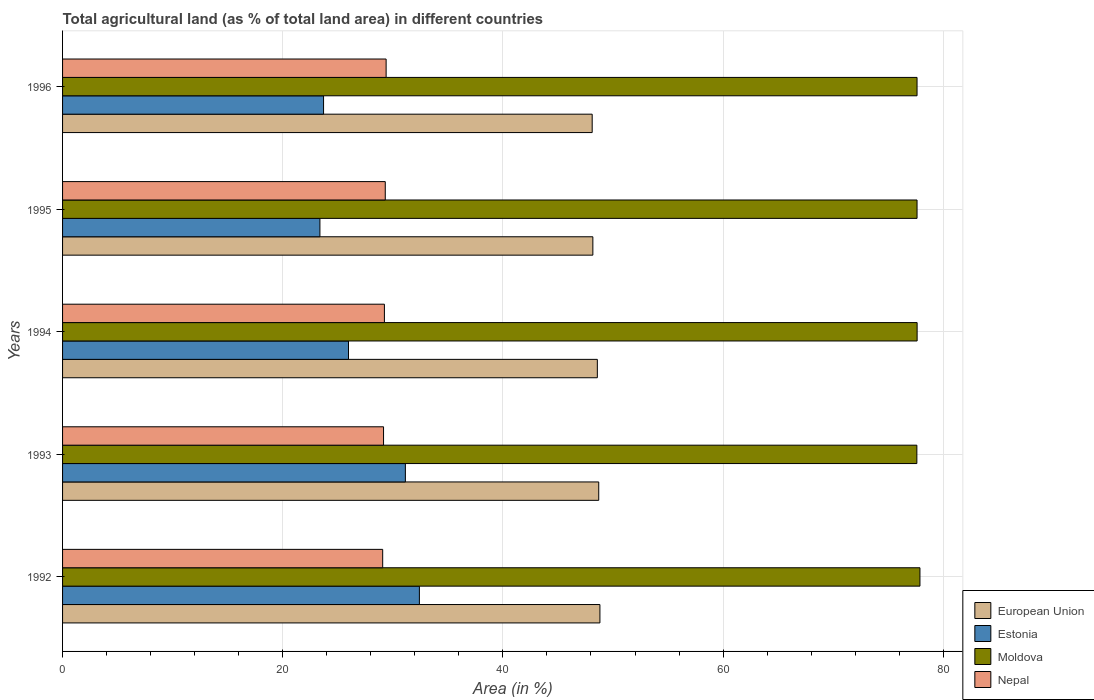How many different coloured bars are there?
Provide a short and direct response. 4. Are the number of bars per tick equal to the number of legend labels?
Provide a succinct answer. Yes. What is the label of the 4th group of bars from the top?
Provide a succinct answer. 1993. In how many cases, is the number of bars for a given year not equal to the number of legend labels?
Give a very brief answer. 0. What is the percentage of agricultural land in Moldova in 1992?
Your answer should be very brief. 77.88. Across all years, what is the maximum percentage of agricultural land in European Union?
Give a very brief answer. 48.81. Across all years, what is the minimum percentage of agricultural land in Estonia?
Keep it short and to the point. 23.38. In which year was the percentage of agricultural land in Estonia maximum?
Make the answer very short. 1992. What is the total percentage of agricultural land in Moldova in the graph?
Your answer should be compact. 388.35. What is the difference between the percentage of agricultural land in Moldova in 1994 and that in 1996?
Provide a succinct answer. 0.01. What is the difference between the percentage of agricultural land in Nepal in 1996 and the percentage of agricultural land in Estonia in 1995?
Offer a terse response. 6.01. What is the average percentage of agricultural land in Nepal per year?
Offer a terse response. 29.23. In the year 1996, what is the difference between the percentage of agricultural land in Estonia and percentage of agricultural land in Nepal?
Provide a short and direct response. -5.68. In how many years, is the percentage of agricultural land in Moldova greater than 72 %?
Your response must be concise. 5. What is the ratio of the percentage of agricultural land in Estonia in 1994 to that in 1995?
Offer a terse response. 1.11. Is the percentage of agricultural land in Moldova in 1995 less than that in 1996?
Keep it short and to the point. No. Is the difference between the percentage of agricultural land in Estonia in 1992 and 1996 greater than the difference between the percentage of agricultural land in Nepal in 1992 and 1996?
Give a very brief answer. Yes. What is the difference between the highest and the second highest percentage of agricultural land in Estonia?
Your answer should be compact. 1.27. What is the difference between the highest and the lowest percentage of agricultural land in European Union?
Your answer should be very brief. 0.7. Is the sum of the percentage of agricultural land in European Union in 1992 and 1995 greater than the maximum percentage of agricultural land in Estonia across all years?
Provide a succinct answer. Yes. What does the 1st bar from the top in 1992 represents?
Give a very brief answer. Nepal. What does the 1st bar from the bottom in 1993 represents?
Make the answer very short. European Union. Where does the legend appear in the graph?
Your response must be concise. Bottom right. How many legend labels are there?
Offer a very short reply. 4. How are the legend labels stacked?
Make the answer very short. Vertical. What is the title of the graph?
Provide a short and direct response. Total agricultural land (as % of total land area) in different countries. What is the label or title of the X-axis?
Your answer should be compact. Area (in %). What is the label or title of the Y-axis?
Offer a terse response. Years. What is the Area (in %) of European Union in 1992?
Make the answer very short. 48.81. What is the Area (in %) of Estonia in 1992?
Ensure brevity in your answer.  32.41. What is the Area (in %) in Moldova in 1992?
Offer a very short reply. 77.88. What is the Area (in %) of Nepal in 1992?
Give a very brief answer. 29.08. What is the Area (in %) in European Union in 1993?
Give a very brief answer. 48.7. What is the Area (in %) of Estonia in 1993?
Your answer should be very brief. 31.14. What is the Area (in %) of Moldova in 1993?
Keep it short and to the point. 77.6. What is the Area (in %) in Nepal in 1993?
Your answer should be very brief. 29.16. What is the Area (in %) of European Union in 1994?
Give a very brief answer. 48.58. What is the Area (in %) in Estonia in 1994?
Your answer should be compact. 25.97. What is the Area (in %) of Moldova in 1994?
Give a very brief answer. 77.63. What is the Area (in %) of Nepal in 1994?
Offer a terse response. 29.23. What is the Area (in %) in European Union in 1995?
Provide a short and direct response. 48.17. What is the Area (in %) in Estonia in 1995?
Provide a short and direct response. 23.38. What is the Area (in %) in Moldova in 1995?
Your answer should be very brief. 77.62. What is the Area (in %) of Nepal in 1995?
Offer a very short reply. 29.31. What is the Area (in %) of European Union in 1996?
Your answer should be compact. 48.11. What is the Area (in %) of Estonia in 1996?
Offer a very short reply. 23.71. What is the Area (in %) in Moldova in 1996?
Provide a short and direct response. 77.62. What is the Area (in %) of Nepal in 1996?
Give a very brief answer. 29.39. Across all years, what is the maximum Area (in %) of European Union?
Offer a very short reply. 48.81. Across all years, what is the maximum Area (in %) in Estonia?
Give a very brief answer. 32.41. Across all years, what is the maximum Area (in %) of Moldova?
Your response must be concise. 77.88. Across all years, what is the maximum Area (in %) in Nepal?
Offer a terse response. 29.39. Across all years, what is the minimum Area (in %) in European Union?
Your response must be concise. 48.11. Across all years, what is the minimum Area (in %) in Estonia?
Keep it short and to the point. 23.38. Across all years, what is the minimum Area (in %) of Moldova?
Your response must be concise. 77.6. Across all years, what is the minimum Area (in %) in Nepal?
Your answer should be compact. 29.08. What is the total Area (in %) in European Union in the graph?
Make the answer very short. 242.37. What is the total Area (in %) in Estonia in the graph?
Your answer should be very brief. 136.61. What is the total Area (in %) in Moldova in the graph?
Your answer should be compact. 388.35. What is the total Area (in %) in Nepal in the graph?
Make the answer very short. 146.17. What is the difference between the Area (in %) in European Union in 1992 and that in 1993?
Provide a succinct answer. 0.11. What is the difference between the Area (in %) of Estonia in 1992 and that in 1993?
Keep it short and to the point. 1.27. What is the difference between the Area (in %) of Moldova in 1992 and that in 1993?
Offer a very short reply. 0.28. What is the difference between the Area (in %) of Nepal in 1992 and that in 1993?
Offer a terse response. -0.08. What is the difference between the Area (in %) of European Union in 1992 and that in 1994?
Make the answer very short. 0.23. What is the difference between the Area (in %) in Estonia in 1992 and that in 1994?
Keep it short and to the point. 6.44. What is the difference between the Area (in %) in Moldova in 1992 and that in 1994?
Your response must be concise. 0.26. What is the difference between the Area (in %) in Nepal in 1992 and that in 1994?
Your response must be concise. -0.16. What is the difference between the Area (in %) in European Union in 1992 and that in 1995?
Offer a very short reply. 0.64. What is the difference between the Area (in %) in Estonia in 1992 and that in 1995?
Keep it short and to the point. 9.04. What is the difference between the Area (in %) of Moldova in 1992 and that in 1995?
Ensure brevity in your answer.  0.26. What is the difference between the Area (in %) of Nepal in 1992 and that in 1995?
Give a very brief answer. -0.23. What is the difference between the Area (in %) in European Union in 1992 and that in 1996?
Give a very brief answer. 0.7. What is the difference between the Area (in %) of Estonia in 1992 and that in 1996?
Keep it short and to the point. 8.7. What is the difference between the Area (in %) in Moldova in 1992 and that in 1996?
Offer a terse response. 0.26. What is the difference between the Area (in %) of Nepal in 1992 and that in 1996?
Provide a succinct answer. -0.31. What is the difference between the Area (in %) in European Union in 1993 and that in 1994?
Provide a short and direct response. 0.13. What is the difference between the Area (in %) in Estonia in 1993 and that in 1994?
Your response must be concise. 5.17. What is the difference between the Area (in %) in Moldova in 1993 and that in 1994?
Offer a terse response. -0.02. What is the difference between the Area (in %) of Nepal in 1993 and that in 1994?
Keep it short and to the point. -0.08. What is the difference between the Area (in %) of European Union in 1993 and that in 1995?
Offer a terse response. 0.53. What is the difference between the Area (in %) of Estonia in 1993 and that in 1995?
Provide a succinct answer. 7.76. What is the difference between the Area (in %) of Moldova in 1993 and that in 1995?
Provide a short and direct response. -0.02. What is the difference between the Area (in %) in Nepal in 1993 and that in 1995?
Offer a very short reply. -0.16. What is the difference between the Area (in %) in European Union in 1993 and that in 1996?
Ensure brevity in your answer.  0.6. What is the difference between the Area (in %) of Estonia in 1993 and that in 1996?
Offer a terse response. 7.43. What is the difference between the Area (in %) of Moldova in 1993 and that in 1996?
Your response must be concise. -0.02. What is the difference between the Area (in %) of Nepal in 1993 and that in 1996?
Your answer should be very brief. -0.23. What is the difference between the Area (in %) in European Union in 1994 and that in 1995?
Your response must be concise. 0.41. What is the difference between the Area (in %) of Estonia in 1994 and that in 1995?
Keep it short and to the point. 2.6. What is the difference between the Area (in %) of Moldova in 1994 and that in 1995?
Ensure brevity in your answer.  0.01. What is the difference between the Area (in %) in Nepal in 1994 and that in 1995?
Offer a very short reply. -0.08. What is the difference between the Area (in %) in European Union in 1994 and that in 1996?
Ensure brevity in your answer.  0.47. What is the difference between the Area (in %) in Estonia in 1994 and that in 1996?
Offer a very short reply. 2.26. What is the difference between the Area (in %) in Moldova in 1994 and that in 1996?
Provide a short and direct response. 0.01. What is the difference between the Area (in %) of Nepal in 1994 and that in 1996?
Your response must be concise. -0.16. What is the difference between the Area (in %) in European Union in 1995 and that in 1996?
Offer a terse response. 0.06. What is the difference between the Area (in %) in Estonia in 1995 and that in 1996?
Give a very brief answer. -0.33. What is the difference between the Area (in %) of Nepal in 1995 and that in 1996?
Provide a succinct answer. -0.08. What is the difference between the Area (in %) of European Union in 1992 and the Area (in %) of Estonia in 1993?
Your response must be concise. 17.67. What is the difference between the Area (in %) in European Union in 1992 and the Area (in %) in Moldova in 1993?
Keep it short and to the point. -28.79. What is the difference between the Area (in %) of European Union in 1992 and the Area (in %) of Nepal in 1993?
Your answer should be very brief. 19.66. What is the difference between the Area (in %) of Estonia in 1992 and the Area (in %) of Moldova in 1993?
Provide a short and direct response. -45.19. What is the difference between the Area (in %) in Estonia in 1992 and the Area (in %) in Nepal in 1993?
Your response must be concise. 3.26. What is the difference between the Area (in %) of Moldova in 1992 and the Area (in %) of Nepal in 1993?
Provide a succinct answer. 48.73. What is the difference between the Area (in %) of European Union in 1992 and the Area (in %) of Estonia in 1994?
Make the answer very short. 22.84. What is the difference between the Area (in %) of European Union in 1992 and the Area (in %) of Moldova in 1994?
Your answer should be very brief. -28.81. What is the difference between the Area (in %) of European Union in 1992 and the Area (in %) of Nepal in 1994?
Offer a very short reply. 19.58. What is the difference between the Area (in %) of Estonia in 1992 and the Area (in %) of Moldova in 1994?
Keep it short and to the point. -45.21. What is the difference between the Area (in %) in Estonia in 1992 and the Area (in %) in Nepal in 1994?
Provide a succinct answer. 3.18. What is the difference between the Area (in %) of Moldova in 1992 and the Area (in %) of Nepal in 1994?
Your answer should be very brief. 48.65. What is the difference between the Area (in %) in European Union in 1992 and the Area (in %) in Estonia in 1995?
Your answer should be compact. 25.43. What is the difference between the Area (in %) of European Union in 1992 and the Area (in %) of Moldova in 1995?
Your answer should be compact. -28.81. What is the difference between the Area (in %) of European Union in 1992 and the Area (in %) of Nepal in 1995?
Ensure brevity in your answer.  19.5. What is the difference between the Area (in %) of Estonia in 1992 and the Area (in %) of Moldova in 1995?
Offer a very short reply. -45.21. What is the difference between the Area (in %) of Estonia in 1992 and the Area (in %) of Nepal in 1995?
Offer a very short reply. 3.1. What is the difference between the Area (in %) in Moldova in 1992 and the Area (in %) in Nepal in 1995?
Your response must be concise. 48.57. What is the difference between the Area (in %) in European Union in 1992 and the Area (in %) in Estonia in 1996?
Offer a terse response. 25.1. What is the difference between the Area (in %) of European Union in 1992 and the Area (in %) of Moldova in 1996?
Give a very brief answer. -28.81. What is the difference between the Area (in %) in European Union in 1992 and the Area (in %) in Nepal in 1996?
Provide a short and direct response. 19.42. What is the difference between the Area (in %) in Estonia in 1992 and the Area (in %) in Moldova in 1996?
Provide a succinct answer. -45.21. What is the difference between the Area (in %) of Estonia in 1992 and the Area (in %) of Nepal in 1996?
Provide a succinct answer. 3.02. What is the difference between the Area (in %) of Moldova in 1992 and the Area (in %) of Nepal in 1996?
Give a very brief answer. 48.49. What is the difference between the Area (in %) of European Union in 1993 and the Area (in %) of Estonia in 1994?
Offer a very short reply. 22.73. What is the difference between the Area (in %) of European Union in 1993 and the Area (in %) of Moldova in 1994?
Offer a very short reply. -28.92. What is the difference between the Area (in %) in European Union in 1993 and the Area (in %) in Nepal in 1994?
Offer a terse response. 19.47. What is the difference between the Area (in %) of Estonia in 1993 and the Area (in %) of Moldova in 1994?
Offer a terse response. -46.49. What is the difference between the Area (in %) of Estonia in 1993 and the Area (in %) of Nepal in 1994?
Give a very brief answer. 1.9. What is the difference between the Area (in %) of Moldova in 1993 and the Area (in %) of Nepal in 1994?
Offer a terse response. 48.37. What is the difference between the Area (in %) in European Union in 1993 and the Area (in %) in Estonia in 1995?
Your answer should be compact. 25.33. What is the difference between the Area (in %) in European Union in 1993 and the Area (in %) in Moldova in 1995?
Provide a short and direct response. -28.91. What is the difference between the Area (in %) of European Union in 1993 and the Area (in %) of Nepal in 1995?
Keep it short and to the point. 19.39. What is the difference between the Area (in %) of Estonia in 1993 and the Area (in %) of Moldova in 1995?
Provide a succinct answer. -46.48. What is the difference between the Area (in %) of Estonia in 1993 and the Area (in %) of Nepal in 1995?
Keep it short and to the point. 1.83. What is the difference between the Area (in %) of Moldova in 1993 and the Area (in %) of Nepal in 1995?
Make the answer very short. 48.29. What is the difference between the Area (in %) in European Union in 1993 and the Area (in %) in Estonia in 1996?
Keep it short and to the point. 25. What is the difference between the Area (in %) in European Union in 1993 and the Area (in %) in Moldova in 1996?
Offer a terse response. -28.91. What is the difference between the Area (in %) in European Union in 1993 and the Area (in %) in Nepal in 1996?
Provide a succinct answer. 19.31. What is the difference between the Area (in %) of Estonia in 1993 and the Area (in %) of Moldova in 1996?
Offer a terse response. -46.48. What is the difference between the Area (in %) of Estonia in 1993 and the Area (in %) of Nepal in 1996?
Make the answer very short. 1.75. What is the difference between the Area (in %) of Moldova in 1993 and the Area (in %) of Nepal in 1996?
Provide a succinct answer. 48.21. What is the difference between the Area (in %) of European Union in 1994 and the Area (in %) of Estonia in 1995?
Your response must be concise. 25.2. What is the difference between the Area (in %) of European Union in 1994 and the Area (in %) of Moldova in 1995?
Give a very brief answer. -29.04. What is the difference between the Area (in %) in European Union in 1994 and the Area (in %) in Nepal in 1995?
Your answer should be very brief. 19.27. What is the difference between the Area (in %) in Estonia in 1994 and the Area (in %) in Moldova in 1995?
Give a very brief answer. -51.65. What is the difference between the Area (in %) in Estonia in 1994 and the Area (in %) in Nepal in 1995?
Your response must be concise. -3.34. What is the difference between the Area (in %) in Moldova in 1994 and the Area (in %) in Nepal in 1995?
Your answer should be very brief. 48.31. What is the difference between the Area (in %) of European Union in 1994 and the Area (in %) of Estonia in 1996?
Offer a terse response. 24.87. What is the difference between the Area (in %) in European Union in 1994 and the Area (in %) in Moldova in 1996?
Ensure brevity in your answer.  -29.04. What is the difference between the Area (in %) of European Union in 1994 and the Area (in %) of Nepal in 1996?
Ensure brevity in your answer.  19.19. What is the difference between the Area (in %) of Estonia in 1994 and the Area (in %) of Moldova in 1996?
Make the answer very short. -51.65. What is the difference between the Area (in %) of Estonia in 1994 and the Area (in %) of Nepal in 1996?
Offer a very short reply. -3.42. What is the difference between the Area (in %) of Moldova in 1994 and the Area (in %) of Nepal in 1996?
Keep it short and to the point. 48.23. What is the difference between the Area (in %) in European Union in 1995 and the Area (in %) in Estonia in 1996?
Provide a succinct answer. 24.46. What is the difference between the Area (in %) of European Union in 1995 and the Area (in %) of Moldova in 1996?
Provide a short and direct response. -29.45. What is the difference between the Area (in %) in European Union in 1995 and the Area (in %) in Nepal in 1996?
Give a very brief answer. 18.78. What is the difference between the Area (in %) of Estonia in 1995 and the Area (in %) of Moldova in 1996?
Provide a succinct answer. -54.24. What is the difference between the Area (in %) of Estonia in 1995 and the Area (in %) of Nepal in 1996?
Provide a succinct answer. -6.01. What is the difference between the Area (in %) of Moldova in 1995 and the Area (in %) of Nepal in 1996?
Keep it short and to the point. 48.23. What is the average Area (in %) in European Union per year?
Make the answer very short. 48.47. What is the average Area (in %) in Estonia per year?
Offer a very short reply. 27.32. What is the average Area (in %) in Moldova per year?
Offer a very short reply. 77.67. What is the average Area (in %) in Nepal per year?
Give a very brief answer. 29.23. In the year 1992, what is the difference between the Area (in %) of European Union and Area (in %) of Estonia?
Offer a very short reply. 16.4. In the year 1992, what is the difference between the Area (in %) of European Union and Area (in %) of Moldova?
Ensure brevity in your answer.  -29.07. In the year 1992, what is the difference between the Area (in %) of European Union and Area (in %) of Nepal?
Make the answer very short. 19.73. In the year 1992, what is the difference between the Area (in %) of Estonia and Area (in %) of Moldova?
Offer a terse response. -45.47. In the year 1992, what is the difference between the Area (in %) of Estonia and Area (in %) of Nepal?
Your answer should be compact. 3.33. In the year 1992, what is the difference between the Area (in %) of Moldova and Area (in %) of Nepal?
Provide a short and direct response. 48.8. In the year 1993, what is the difference between the Area (in %) of European Union and Area (in %) of Estonia?
Make the answer very short. 17.57. In the year 1993, what is the difference between the Area (in %) of European Union and Area (in %) of Moldova?
Offer a terse response. -28.9. In the year 1993, what is the difference between the Area (in %) of European Union and Area (in %) of Nepal?
Ensure brevity in your answer.  19.55. In the year 1993, what is the difference between the Area (in %) in Estonia and Area (in %) in Moldova?
Keep it short and to the point. -46.46. In the year 1993, what is the difference between the Area (in %) of Estonia and Area (in %) of Nepal?
Offer a terse response. 1.98. In the year 1993, what is the difference between the Area (in %) of Moldova and Area (in %) of Nepal?
Ensure brevity in your answer.  48.45. In the year 1994, what is the difference between the Area (in %) in European Union and Area (in %) in Estonia?
Your response must be concise. 22.61. In the year 1994, what is the difference between the Area (in %) of European Union and Area (in %) of Moldova?
Your answer should be compact. -29.05. In the year 1994, what is the difference between the Area (in %) in European Union and Area (in %) in Nepal?
Offer a terse response. 19.34. In the year 1994, what is the difference between the Area (in %) in Estonia and Area (in %) in Moldova?
Ensure brevity in your answer.  -51.65. In the year 1994, what is the difference between the Area (in %) in Estonia and Area (in %) in Nepal?
Provide a short and direct response. -3.26. In the year 1994, what is the difference between the Area (in %) of Moldova and Area (in %) of Nepal?
Provide a succinct answer. 48.39. In the year 1995, what is the difference between the Area (in %) in European Union and Area (in %) in Estonia?
Give a very brief answer. 24.79. In the year 1995, what is the difference between the Area (in %) of European Union and Area (in %) of Moldova?
Keep it short and to the point. -29.45. In the year 1995, what is the difference between the Area (in %) of European Union and Area (in %) of Nepal?
Ensure brevity in your answer.  18.86. In the year 1995, what is the difference between the Area (in %) of Estonia and Area (in %) of Moldova?
Offer a very short reply. -54.24. In the year 1995, what is the difference between the Area (in %) of Estonia and Area (in %) of Nepal?
Make the answer very short. -5.94. In the year 1995, what is the difference between the Area (in %) in Moldova and Area (in %) in Nepal?
Offer a terse response. 48.31. In the year 1996, what is the difference between the Area (in %) of European Union and Area (in %) of Estonia?
Offer a very short reply. 24.4. In the year 1996, what is the difference between the Area (in %) in European Union and Area (in %) in Moldova?
Make the answer very short. -29.51. In the year 1996, what is the difference between the Area (in %) in European Union and Area (in %) in Nepal?
Provide a succinct answer. 18.72. In the year 1996, what is the difference between the Area (in %) of Estonia and Area (in %) of Moldova?
Provide a succinct answer. -53.91. In the year 1996, what is the difference between the Area (in %) in Estonia and Area (in %) in Nepal?
Offer a terse response. -5.68. In the year 1996, what is the difference between the Area (in %) in Moldova and Area (in %) in Nepal?
Make the answer very short. 48.23. What is the ratio of the Area (in %) in European Union in 1992 to that in 1993?
Offer a terse response. 1. What is the ratio of the Area (in %) in Estonia in 1992 to that in 1993?
Offer a terse response. 1.04. What is the ratio of the Area (in %) in Moldova in 1992 to that in 1993?
Give a very brief answer. 1. What is the ratio of the Area (in %) in Nepal in 1992 to that in 1993?
Give a very brief answer. 1. What is the ratio of the Area (in %) in European Union in 1992 to that in 1994?
Provide a succinct answer. 1. What is the ratio of the Area (in %) of Estonia in 1992 to that in 1994?
Offer a very short reply. 1.25. What is the ratio of the Area (in %) in Nepal in 1992 to that in 1994?
Offer a terse response. 0.99. What is the ratio of the Area (in %) of European Union in 1992 to that in 1995?
Provide a succinct answer. 1.01. What is the ratio of the Area (in %) in Estonia in 1992 to that in 1995?
Offer a terse response. 1.39. What is the ratio of the Area (in %) of Moldova in 1992 to that in 1995?
Give a very brief answer. 1. What is the ratio of the Area (in %) of European Union in 1992 to that in 1996?
Offer a terse response. 1.01. What is the ratio of the Area (in %) in Estonia in 1992 to that in 1996?
Offer a very short reply. 1.37. What is the ratio of the Area (in %) of Moldova in 1992 to that in 1996?
Provide a short and direct response. 1. What is the ratio of the Area (in %) in Nepal in 1992 to that in 1996?
Your response must be concise. 0.99. What is the ratio of the Area (in %) in Estonia in 1993 to that in 1994?
Offer a very short reply. 1.2. What is the ratio of the Area (in %) in Moldova in 1993 to that in 1994?
Your answer should be compact. 1. What is the ratio of the Area (in %) in Nepal in 1993 to that in 1994?
Give a very brief answer. 1. What is the ratio of the Area (in %) of European Union in 1993 to that in 1995?
Ensure brevity in your answer.  1.01. What is the ratio of the Area (in %) of Estonia in 1993 to that in 1995?
Make the answer very short. 1.33. What is the ratio of the Area (in %) of Moldova in 1993 to that in 1995?
Offer a terse response. 1. What is the ratio of the Area (in %) of Nepal in 1993 to that in 1995?
Your response must be concise. 0.99. What is the ratio of the Area (in %) of European Union in 1993 to that in 1996?
Provide a succinct answer. 1.01. What is the ratio of the Area (in %) in Estonia in 1993 to that in 1996?
Ensure brevity in your answer.  1.31. What is the ratio of the Area (in %) in Moldova in 1993 to that in 1996?
Ensure brevity in your answer.  1. What is the ratio of the Area (in %) of European Union in 1994 to that in 1995?
Keep it short and to the point. 1.01. What is the ratio of the Area (in %) in Estonia in 1994 to that in 1995?
Provide a succinct answer. 1.11. What is the ratio of the Area (in %) of European Union in 1994 to that in 1996?
Offer a very short reply. 1.01. What is the ratio of the Area (in %) of Estonia in 1994 to that in 1996?
Offer a terse response. 1.1. What is the ratio of the Area (in %) in Moldova in 1994 to that in 1996?
Your answer should be compact. 1. What is the ratio of the Area (in %) of Nepal in 1994 to that in 1996?
Your response must be concise. 0.99. What is the ratio of the Area (in %) in Estonia in 1995 to that in 1996?
Offer a terse response. 0.99. What is the ratio of the Area (in %) in Moldova in 1995 to that in 1996?
Provide a succinct answer. 1. What is the difference between the highest and the second highest Area (in %) of European Union?
Offer a terse response. 0.11. What is the difference between the highest and the second highest Area (in %) in Estonia?
Your answer should be compact. 1.27. What is the difference between the highest and the second highest Area (in %) in Moldova?
Your response must be concise. 0.26. What is the difference between the highest and the second highest Area (in %) in Nepal?
Keep it short and to the point. 0.08. What is the difference between the highest and the lowest Area (in %) in European Union?
Your answer should be very brief. 0.7. What is the difference between the highest and the lowest Area (in %) of Estonia?
Offer a very short reply. 9.04. What is the difference between the highest and the lowest Area (in %) in Moldova?
Your response must be concise. 0.28. What is the difference between the highest and the lowest Area (in %) of Nepal?
Your response must be concise. 0.31. 